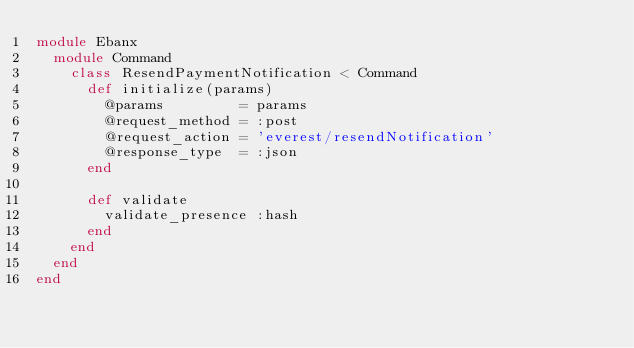Convert code to text. <code><loc_0><loc_0><loc_500><loc_500><_Ruby_>module Ebanx
  module Command
    class ResendPaymentNotification < Command
      def initialize(params)
        @params         = params
        @request_method = :post
        @request_action = 'everest/resendNotification'
        @response_type  = :json
      end

      def validate
        validate_presence :hash
      end
    end
  end
end</code> 